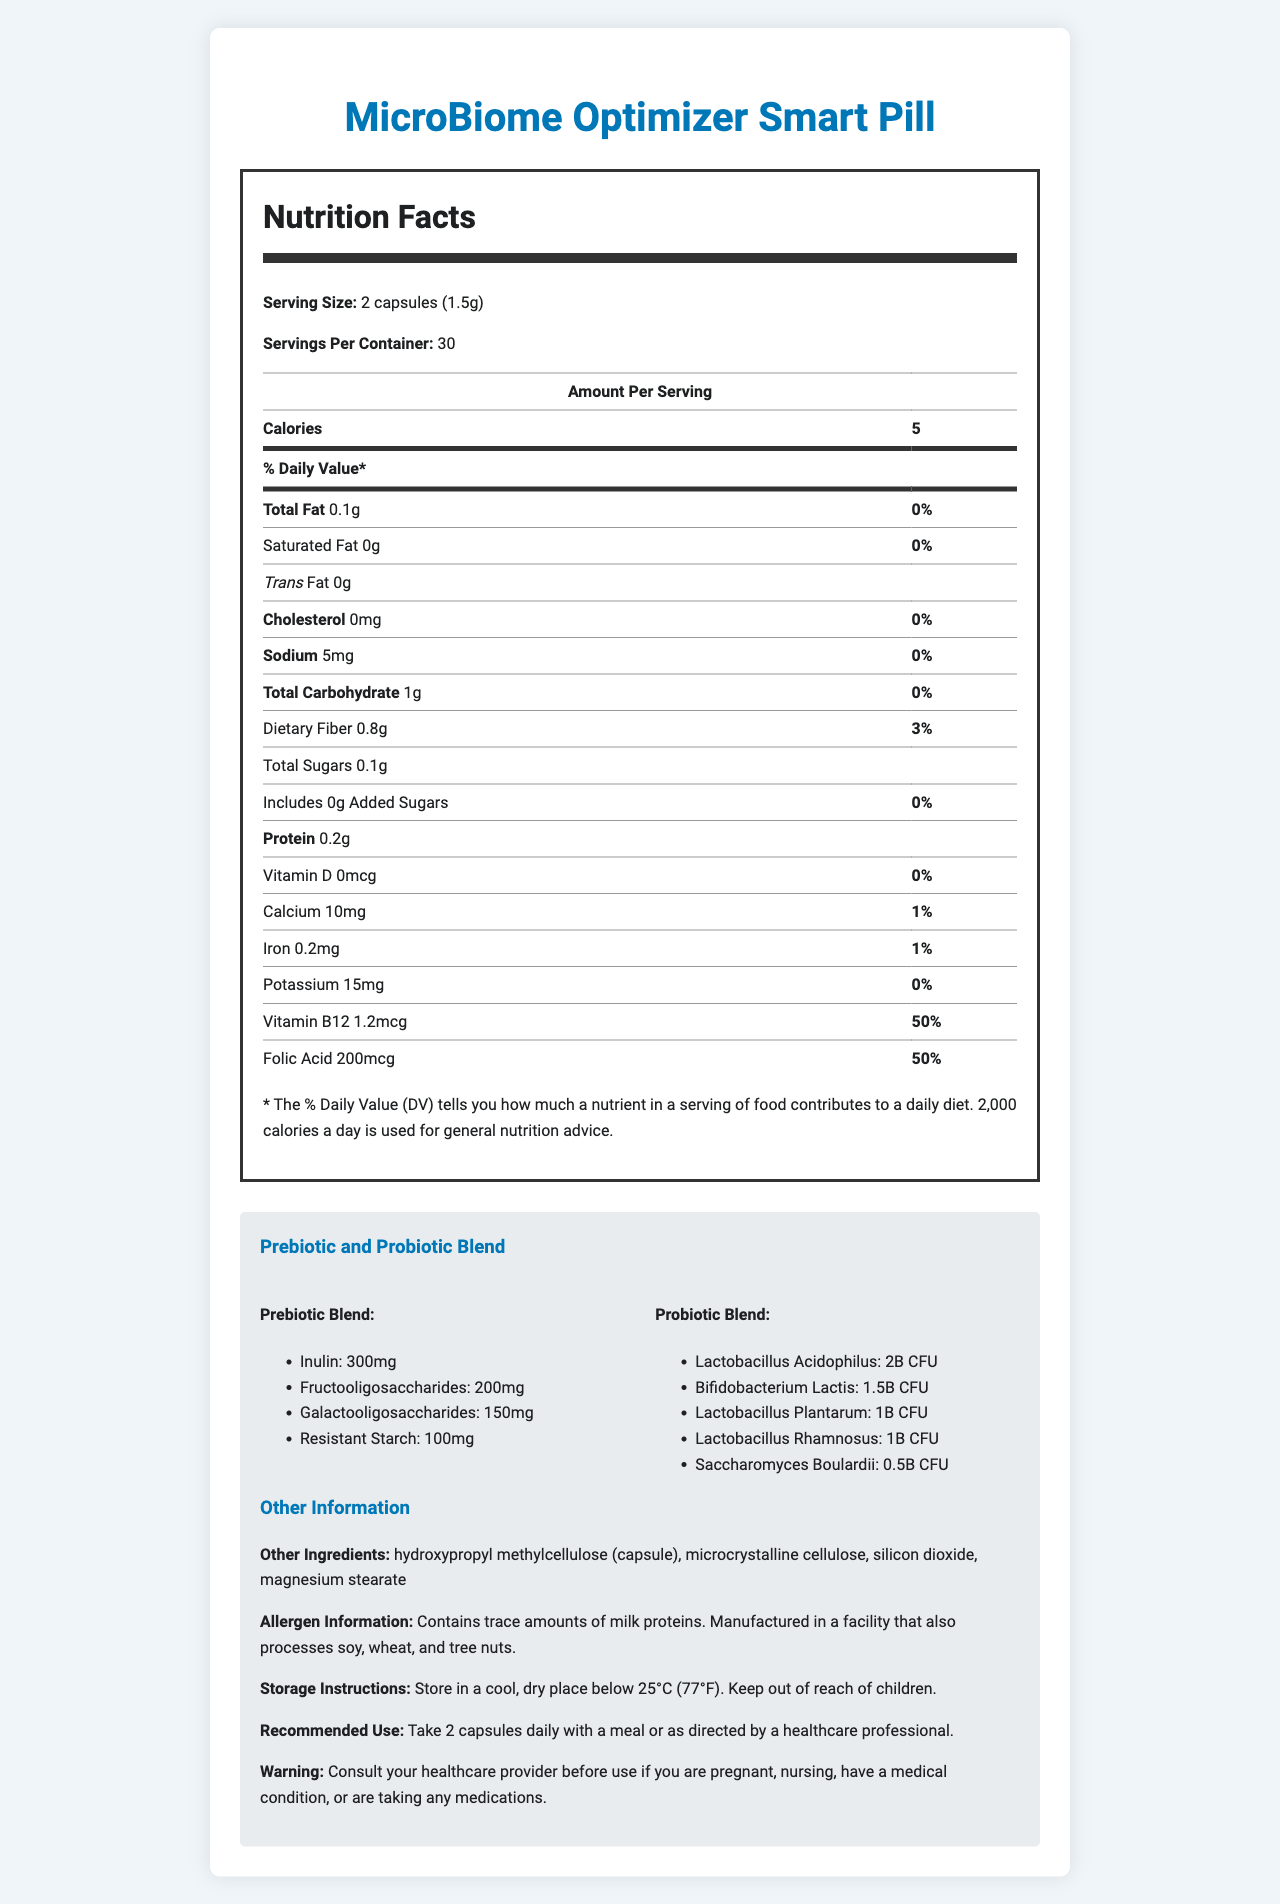how many calories are in a serving of the MicroBiome Optimizer Smart Pill? The nutrition facts section lists the calorie content per serving as 5 calories.
Answer: 5 what is the serving size of the MicroBiome Optimizer Smart Pill? The serving size is specified in the document as 2 capsules (1.5g).
Answer: 2 capsules (1.5g) how much dietary fiber is in a serving? The nutritional information lists the dietary fiber content per serving as 0.8 grams.
Answer: 0.8 grams list the microorganisms included in the probiotic blend. The probiotic blend section details all the microorganisms included in the pill.
Answer: Lactobacillus acidophilus, Bifidobacterium lactis, Lactobacillus plantarum, Lactobacillus rhamnosus, Saccharomyces boulardii what is the recommended use of the MicroBiome Optimizer Smart Pill? The recommended use is stated in the other information section of the document.
Answer: Take 2 capsules daily with a meal or as directed by a healthcare professional which of the following is NOT an ingredient in the prebiotic blend? A. Inulin B. Galactooligosaccharides C. Saccharomyces boulardii D. Resistant Starch Saccharomyces boulardii is part of the probiotic blend, not the prebiotic blend.
Answer: C what is a unique feature of the smart coating technology used in this product? A. Color-changing properties B. pH-responsive polymer for targeted release in the intestines C. Magnetic activation D. UV light sensitivity The document specifies the smart coating uses a pH-responsive polymer for targeted release in the intestines.
Answer: B does the product contain any added sugars? The nutritional information shows 0 grams of added sugars per serving.
Answer: No describe the primary purposes and benefits highlighted in the document regarding the MicroBiome Optimizer Smart Pill. The document focuses on gut health improvement through specific blends, advanced technology for release and monitoring, proven clinical benefits, and sustainability efforts.
Answer: The document highlights the optimization of gut microbiome health through the inclusion of prebiotic and probiotic blends. It mentions the smart coating for targeted release, real-time gut health monitoring, and the significant improvements noted in clinical studies. Sustainability of packaging and ethical ingredient sourcing are also emphasized. can the product be used by pregnant women without consulting a healthcare provider? The warning section advises consulting a healthcare provider before use if you are pregnant or nursing.
Answer: No what is the complete list of other ingredients in the product? The other information section of the document lists these as the other ingredients.
Answer: Hydroxypropyl methylcellulose (capsule), microcrystalline cellulose, silicon dioxide, magnesium stearate how much calcium is in a serving of the MicroBiome Optimizer Smart Pill? The nutritional information lists the calcium content per serving as 10 mg.
Answer: 10 mg does the pill contain any cholesterol? The nutritional information shows 0 mg of cholesterol per serving.
Answer: No what is the total amount of prebiotics in a serving? Adding the amounts listed in the prebiotic blend section (300 mg of Inulin, 200 mg of Fructooligosaccharides, 150 mg of Galactooligosaccharides, 100 mg of Resistant Starch) gives a total of 750 mg.
Answer: 750 mg what are the key findings from the clinical study titled "Impact of MicroBiome Optimizer on Gut Health Markers"? The key findings from this study are clearly stated in the clinical studies section.
Answer: Significant improvement in microbial diversity and short-chain fatty acid production how much folic acid is in a serving? The nutritional information lists the folic acid content per serving as 200 mcg.
Answer: 200 mcg what is the pH-responsive polymer used for in the product's technology? The technology integration section specifies that the pH-responsive polymer is used for targeted release in the intestines.
Answer: Targeted release in the intestines how should the MicroBiome Optimizer Smart Pill be stored? The storage instructions are detailed in the other information section of the document.
Answer: Store in a cool, dry place below 25°C (77°F). Keep out of reach of children. how would you rate the environmental impact of the product's packaging? A. Low B. Moderate C. High D. Cannot be determined The document mentions that the packaging is 100% recyclable and made from 30% post-consumer recycled materials, indicating a low environmental impact.
Answer: A what is the effect of the product on short-chain fatty acid production according to clinical studies? This information is directly stated in the key findings of the clinical study mentioned in the document.
Answer: The clinical study "Impact of MicroBiome Optimizer on Gut Health Markers" reports significant improvement in short-chain fatty acid production 